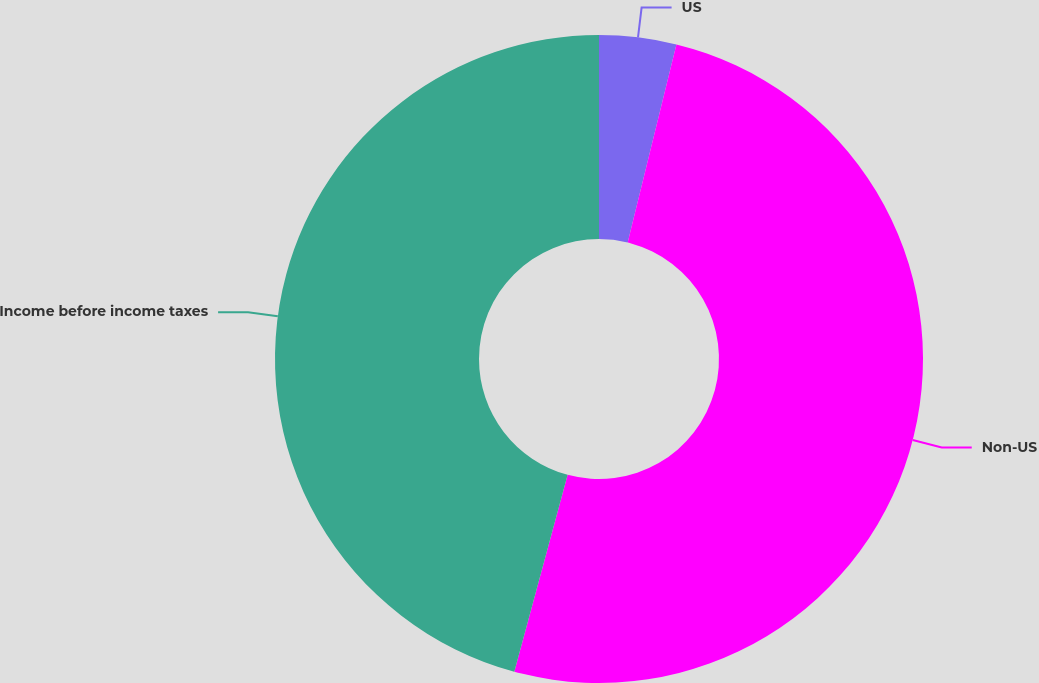Convert chart to OTSL. <chart><loc_0><loc_0><loc_500><loc_500><pie_chart><fcel>US<fcel>Non-US<fcel>Income before income taxes<nl><fcel>3.84%<fcel>50.37%<fcel>45.79%<nl></chart> 